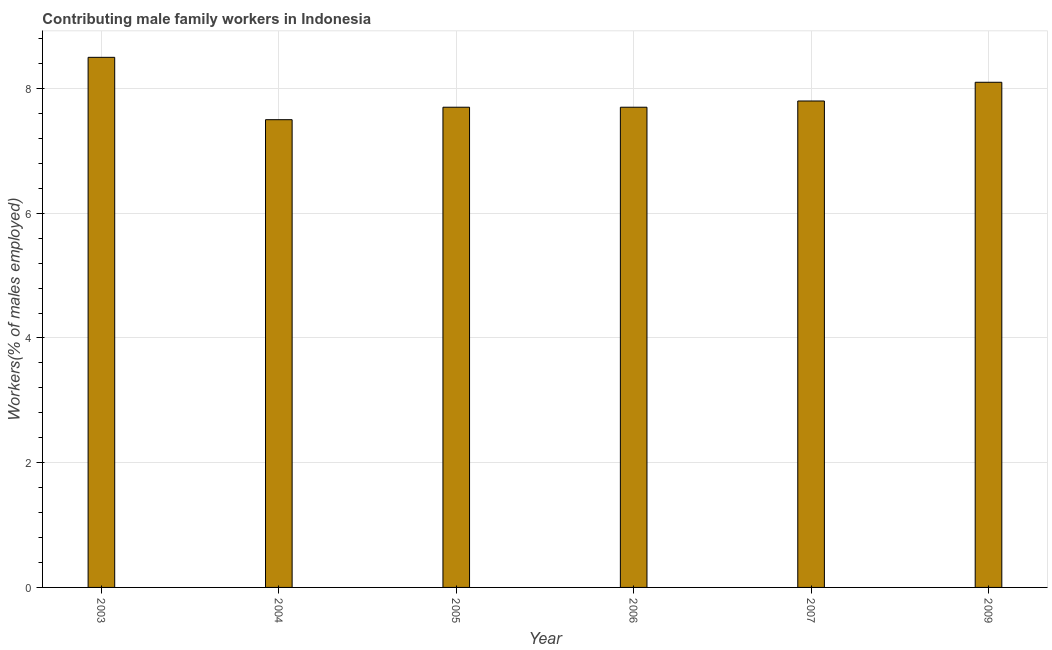Does the graph contain any zero values?
Keep it short and to the point. No. Does the graph contain grids?
Ensure brevity in your answer.  Yes. What is the title of the graph?
Give a very brief answer. Contributing male family workers in Indonesia. What is the label or title of the Y-axis?
Your answer should be compact. Workers(% of males employed). What is the contributing male family workers in 2006?
Your response must be concise. 7.7. Across all years, what is the maximum contributing male family workers?
Keep it short and to the point. 8.5. Across all years, what is the minimum contributing male family workers?
Give a very brief answer. 7.5. In which year was the contributing male family workers maximum?
Your response must be concise. 2003. What is the sum of the contributing male family workers?
Your answer should be compact. 47.3. What is the difference between the contributing male family workers in 2007 and 2009?
Provide a succinct answer. -0.3. What is the average contributing male family workers per year?
Give a very brief answer. 7.88. What is the median contributing male family workers?
Ensure brevity in your answer.  7.75. Do a majority of the years between 2004 and 2005 (inclusive) have contributing male family workers greater than 2 %?
Keep it short and to the point. Yes. What is the ratio of the contributing male family workers in 2004 to that in 2009?
Give a very brief answer. 0.93. Is the contributing male family workers in 2003 less than that in 2007?
Ensure brevity in your answer.  No. What is the difference between the highest and the lowest contributing male family workers?
Your response must be concise. 1. What is the difference between two consecutive major ticks on the Y-axis?
Your response must be concise. 2. Are the values on the major ticks of Y-axis written in scientific E-notation?
Provide a short and direct response. No. What is the Workers(% of males employed) in 2003?
Make the answer very short. 8.5. What is the Workers(% of males employed) of 2004?
Provide a short and direct response. 7.5. What is the Workers(% of males employed) of 2005?
Ensure brevity in your answer.  7.7. What is the Workers(% of males employed) in 2006?
Keep it short and to the point. 7.7. What is the Workers(% of males employed) of 2007?
Make the answer very short. 7.8. What is the Workers(% of males employed) of 2009?
Offer a very short reply. 8.1. What is the difference between the Workers(% of males employed) in 2003 and 2004?
Keep it short and to the point. 1. What is the difference between the Workers(% of males employed) in 2003 and 2005?
Your response must be concise. 0.8. What is the difference between the Workers(% of males employed) in 2003 and 2006?
Offer a terse response. 0.8. What is the difference between the Workers(% of males employed) in 2003 and 2007?
Ensure brevity in your answer.  0.7. What is the difference between the Workers(% of males employed) in 2003 and 2009?
Provide a succinct answer. 0.4. What is the difference between the Workers(% of males employed) in 2004 and 2009?
Your response must be concise. -0.6. What is the difference between the Workers(% of males employed) in 2005 and 2006?
Offer a very short reply. 0. What is the difference between the Workers(% of males employed) in 2005 and 2007?
Ensure brevity in your answer.  -0.1. What is the difference between the Workers(% of males employed) in 2005 and 2009?
Your answer should be very brief. -0.4. What is the difference between the Workers(% of males employed) in 2006 and 2009?
Make the answer very short. -0.4. What is the difference between the Workers(% of males employed) in 2007 and 2009?
Offer a terse response. -0.3. What is the ratio of the Workers(% of males employed) in 2003 to that in 2004?
Make the answer very short. 1.13. What is the ratio of the Workers(% of males employed) in 2003 to that in 2005?
Your answer should be compact. 1.1. What is the ratio of the Workers(% of males employed) in 2003 to that in 2006?
Give a very brief answer. 1.1. What is the ratio of the Workers(% of males employed) in 2003 to that in 2007?
Provide a succinct answer. 1.09. What is the ratio of the Workers(% of males employed) in 2003 to that in 2009?
Offer a terse response. 1.05. What is the ratio of the Workers(% of males employed) in 2004 to that in 2009?
Ensure brevity in your answer.  0.93. What is the ratio of the Workers(% of males employed) in 2005 to that in 2009?
Your answer should be very brief. 0.95. What is the ratio of the Workers(% of males employed) in 2006 to that in 2007?
Offer a very short reply. 0.99. What is the ratio of the Workers(% of males employed) in 2006 to that in 2009?
Offer a very short reply. 0.95. 